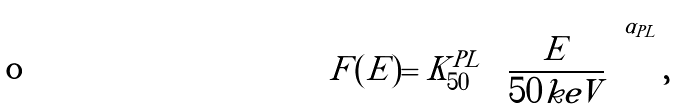Convert formula to latex. <formula><loc_0><loc_0><loc_500><loc_500>F ( E ) = K ^ { P L } _ { 5 0 } \left ( \frac { E } { 5 0 k e V } \right ) ^ { \alpha _ { P L } } ,</formula> 